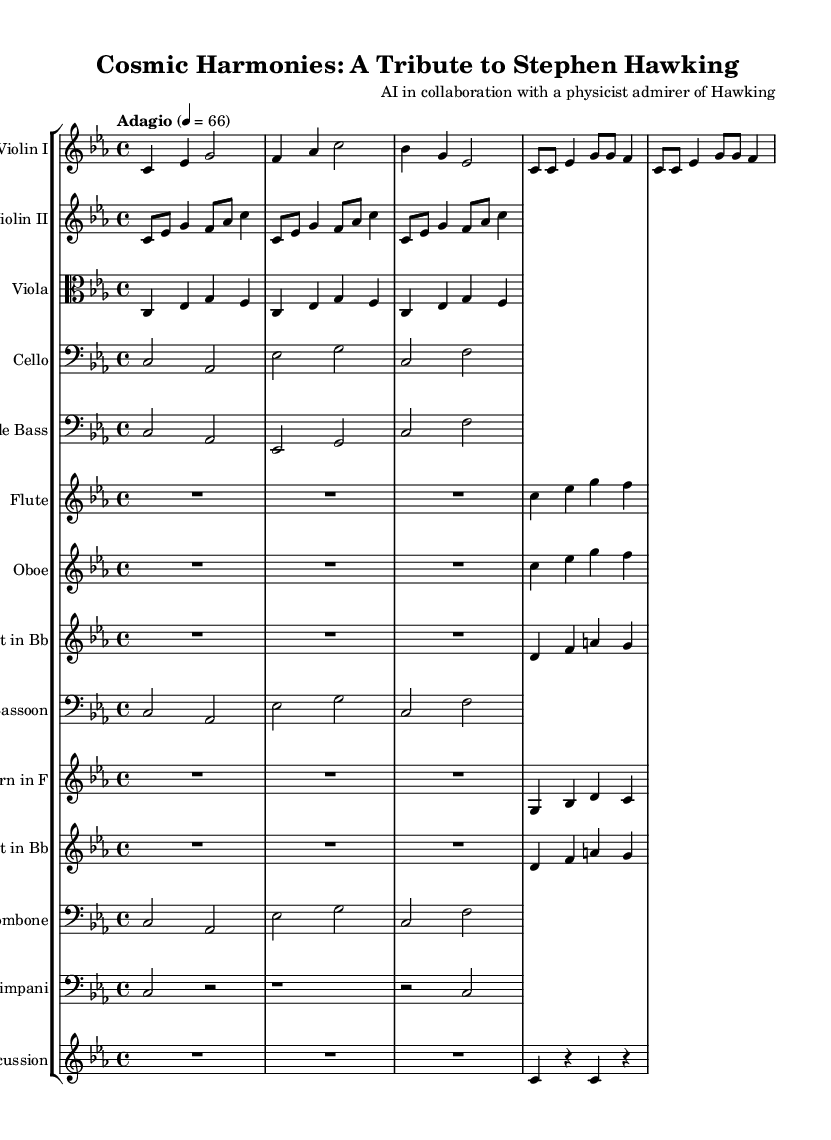What is the key signature of this music? The key signature is indicated at the beginning of the sheet music, showing that there are three flats (B♭, E♭, and A♭), which designates it as C minor.
Answer: C minor What is the time signature of this music? The time signature is found at the beginning of the score, presented as 4/4, meaning there are four beats in a measure and the quarter note gets one beat.
Answer: 4/4 What is the tempo marking of this music? The tempo marking specifies the speed of the music, which in this case is 'Adagio', and denotes a slow pace, with a metronome marking of 66 beats per minute.
Answer: Adagio How many instruments are featured in this symphony? By examining the score, we can count the number of different staves, which include instruments like violins, viola, cello, and various woodwinds and brass, totaling 13 distinct instruments.
Answer: 13 What is the instrument transposition for the clarinet? The clarinet part is written in B♭, meaning that to sound a concert pitch of C, the player must play a D note; this is indicated by the transposition marking at the beginning of the clarinet part.
Answer: B♭ How many measures are in the first violin part? The first violin part contains a total of 8 measures, as counted by the horizontal layout and separation shown on the staff, indicating how many distinct measures are present.
Answer: 8 